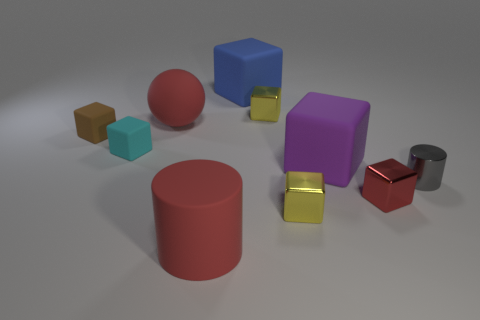What shape is the red object that is in front of the cyan rubber object and left of the tiny red shiny cube?
Provide a short and direct response. Cylinder. How many metal objects are in front of the purple thing behind the yellow shiny object that is in front of the purple rubber cube?
Provide a succinct answer. 3. There is a cyan thing that is the same shape as the tiny red thing; what size is it?
Keep it short and to the point. Small. Do the yellow object that is in front of the large sphere and the purple thing have the same material?
Your answer should be compact. No. The other big object that is the same shape as the big blue rubber thing is what color?
Offer a very short reply. Purple. How many other things are there of the same color as the big cylinder?
Provide a succinct answer. 2. Does the big red thing that is to the left of the large red rubber cylinder have the same shape as the big rubber thing that is right of the blue matte object?
Provide a succinct answer. No. How many cylinders are tiny blue things or cyan matte things?
Give a very brief answer. 0. Is the number of small gray cylinders that are left of the large purple matte thing less than the number of red balls?
Give a very brief answer. Yes. How many other things are made of the same material as the big blue thing?
Make the answer very short. 5. 